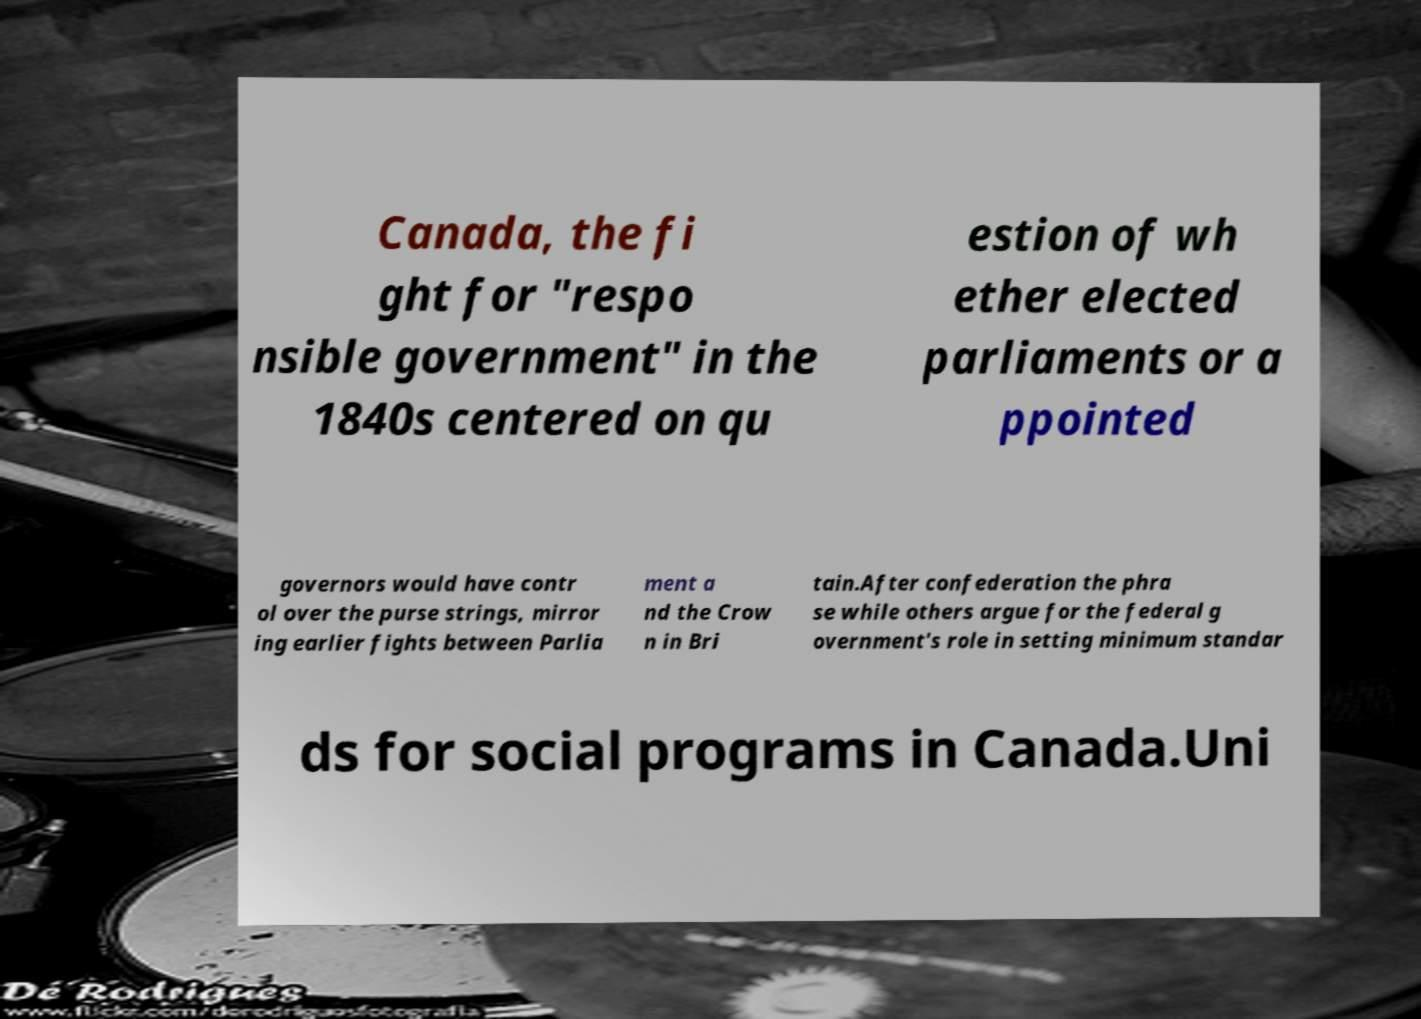I need the written content from this picture converted into text. Can you do that? Canada, the fi ght for "respo nsible government" in the 1840s centered on qu estion of wh ether elected parliaments or a ppointed governors would have contr ol over the purse strings, mirror ing earlier fights between Parlia ment a nd the Crow n in Bri tain.After confederation the phra se while others argue for the federal g overnment's role in setting minimum standar ds for social programs in Canada.Uni 